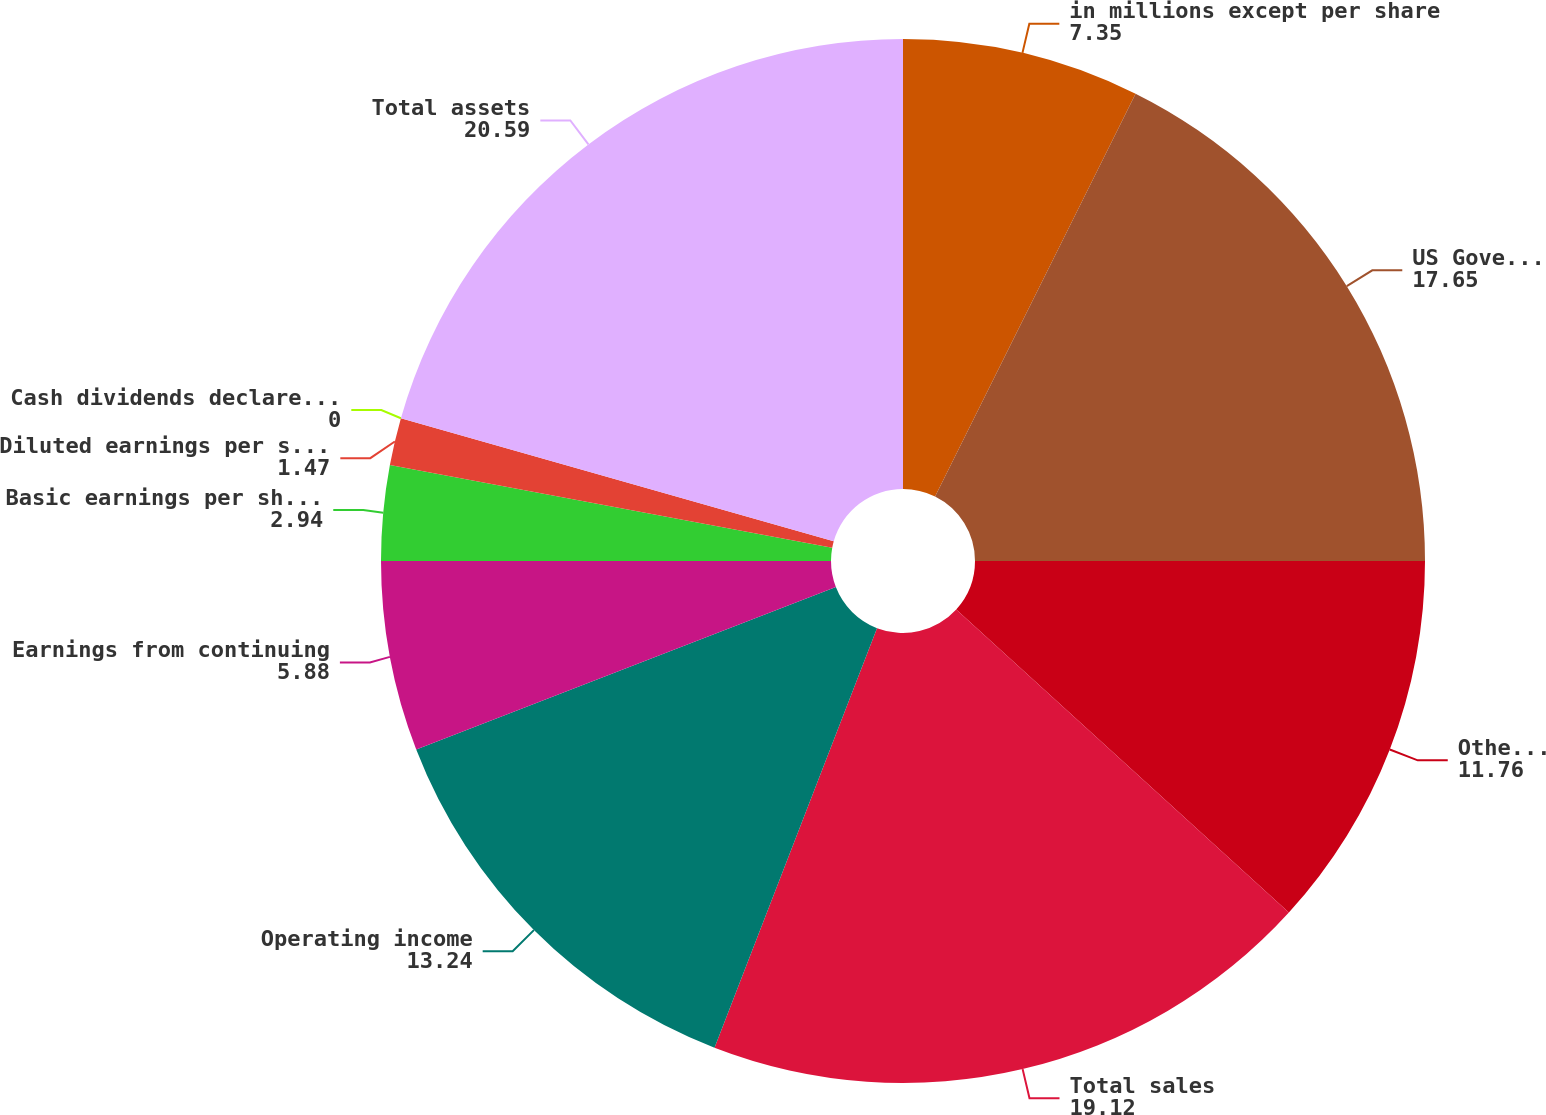<chart> <loc_0><loc_0><loc_500><loc_500><pie_chart><fcel>in millions except per share<fcel>US Government<fcel>Other customers (1)<fcel>Total sales<fcel>Operating income<fcel>Earnings from continuing<fcel>Basic earnings per share from<fcel>Diluted earnings per share<fcel>Cash dividends declared per<fcel>Total assets<nl><fcel>7.35%<fcel>17.65%<fcel>11.76%<fcel>19.12%<fcel>13.24%<fcel>5.88%<fcel>2.94%<fcel>1.47%<fcel>0.0%<fcel>20.59%<nl></chart> 